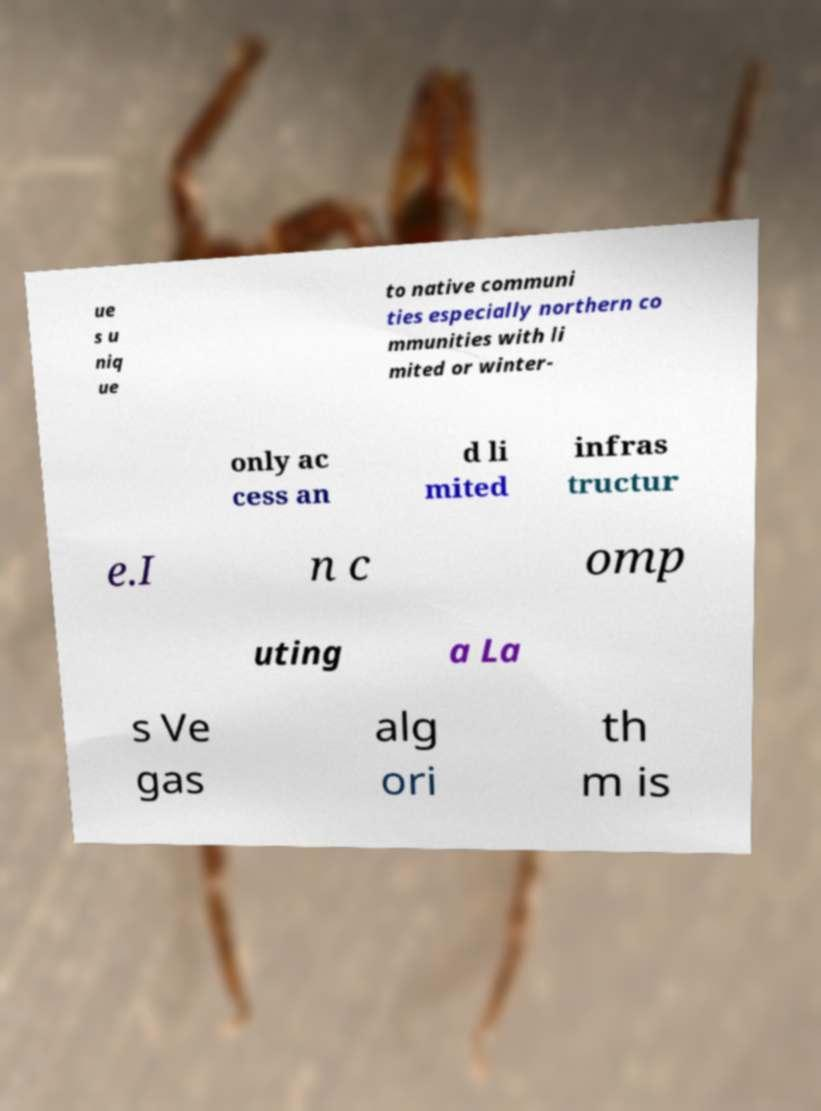Could you extract and type out the text from this image? ue s u niq ue to native communi ties especially northern co mmunities with li mited or winter- only ac cess an d li mited infras tructur e.I n c omp uting a La s Ve gas alg ori th m is 